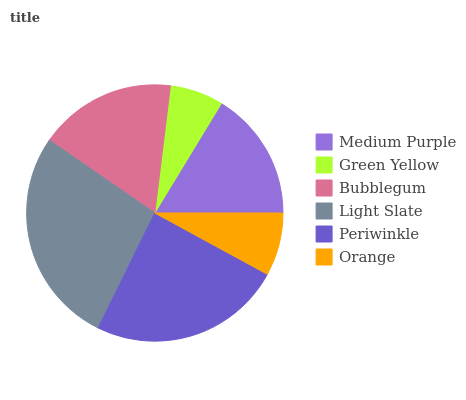Is Green Yellow the minimum?
Answer yes or no. Yes. Is Light Slate the maximum?
Answer yes or no. Yes. Is Bubblegum the minimum?
Answer yes or no. No. Is Bubblegum the maximum?
Answer yes or no. No. Is Bubblegum greater than Green Yellow?
Answer yes or no. Yes. Is Green Yellow less than Bubblegum?
Answer yes or no. Yes. Is Green Yellow greater than Bubblegum?
Answer yes or no. No. Is Bubblegum less than Green Yellow?
Answer yes or no. No. Is Bubblegum the high median?
Answer yes or no. Yes. Is Medium Purple the low median?
Answer yes or no. Yes. Is Green Yellow the high median?
Answer yes or no. No. Is Orange the low median?
Answer yes or no. No. 